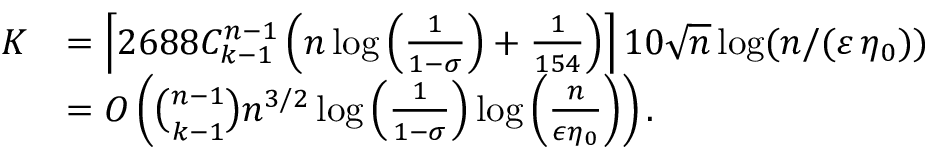Convert formula to latex. <formula><loc_0><loc_0><loc_500><loc_500>\begin{array} { r l } { K } & { = \left \lceil 2 6 8 8 { C _ { k - 1 } ^ { n - 1 } } \left ( n \log \left ( \frac { 1 } { 1 - \sigma } \right ) + \frac { 1 } { 1 5 4 } \right ) \right \rceil 1 0 \sqrt { n } \log ( n / ( \varepsilon \, \eta _ { 0 } ) ) } \\ & { = O \left ( { \binom { n - 1 } { k - 1 } } n ^ { 3 / 2 } \log \left ( \frac { 1 } { 1 - \sigma } \right ) \log \left ( \frac { n } { \epsilon \eta _ { 0 } } \right ) \right ) . } \end{array}</formula> 